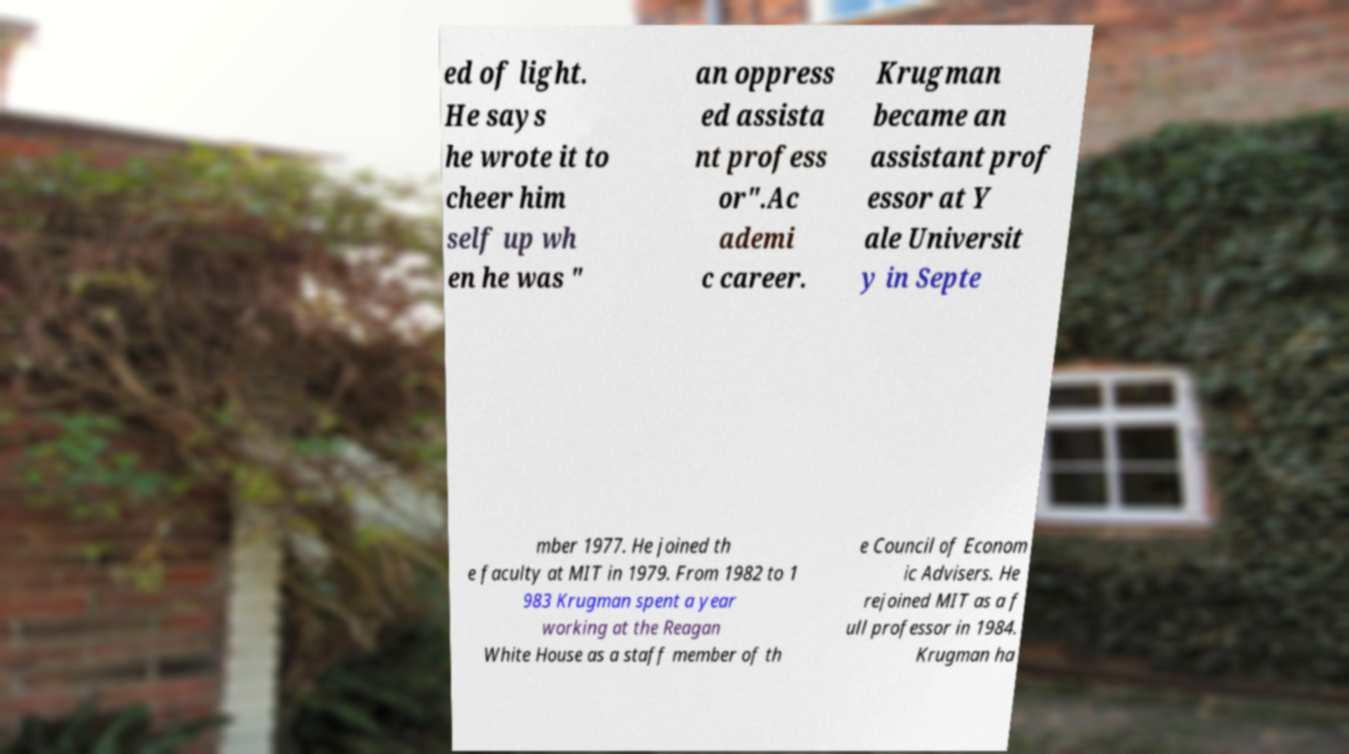Can you read and provide the text displayed in the image?This photo seems to have some interesting text. Can you extract and type it out for me? ed of light. He says he wrote it to cheer him self up wh en he was " an oppress ed assista nt profess or".Ac ademi c career. Krugman became an assistant prof essor at Y ale Universit y in Septe mber 1977. He joined th e faculty at MIT in 1979. From 1982 to 1 983 Krugman spent a year working at the Reagan White House as a staff member of th e Council of Econom ic Advisers. He rejoined MIT as a f ull professor in 1984. Krugman ha 